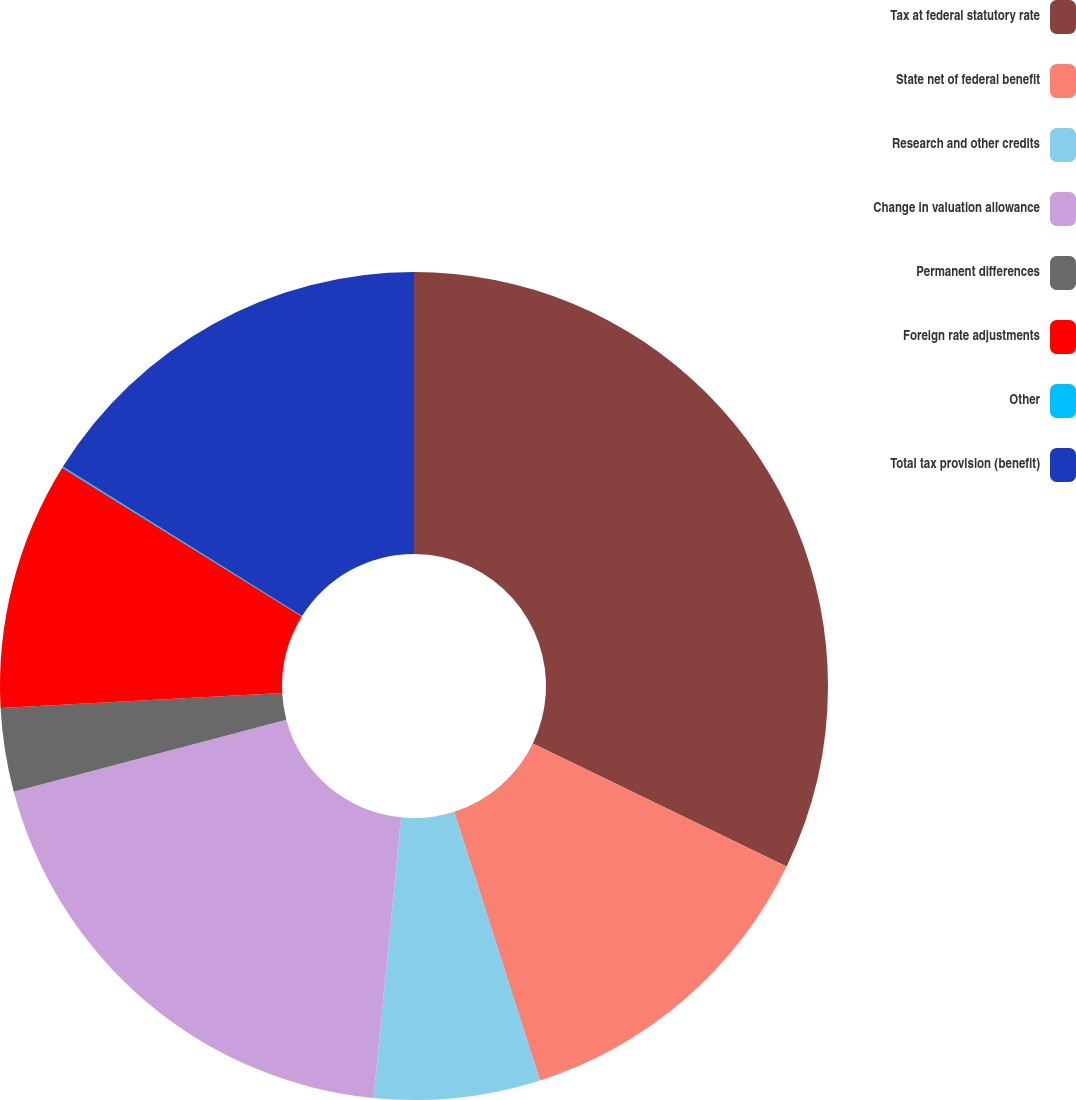Convert chart. <chart><loc_0><loc_0><loc_500><loc_500><pie_chart><fcel>Tax at federal statutory rate<fcel>State net of federal benefit<fcel>Research and other credits<fcel>Change in valuation allowance<fcel>Permanent differences<fcel>Foreign rate adjustments<fcel>Other<fcel>Total tax provision (benefit)<nl><fcel>32.18%<fcel>12.9%<fcel>6.48%<fcel>19.33%<fcel>3.26%<fcel>9.69%<fcel>0.05%<fcel>16.11%<nl></chart> 